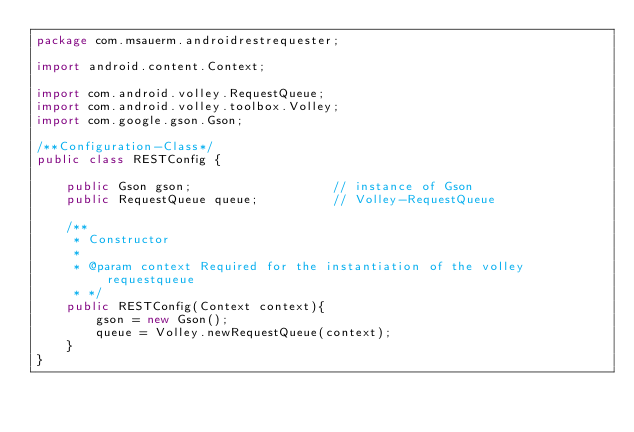Convert code to text. <code><loc_0><loc_0><loc_500><loc_500><_Java_>package com.msauerm.androidrestrequester;

import android.content.Context;

import com.android.volley.RequestQueue;
import com.android.volley.toolbox.Volley;
import com.google.gson.Gson;

/**Configuration-Class*/
public class RESTConfig {

    public Gson gson;                   // instance of Gson
    public RequestQueue queue;          // Volley-RequestQueue

    /**
     * Constructor
     *
     * @param context Required for the instantiation of the volley requestqueue
     * */
    public RESTConfig(Context context){
        gson = new Gson();
        queue = Volley.newRequestQueue(context);
    }
}
</code> 